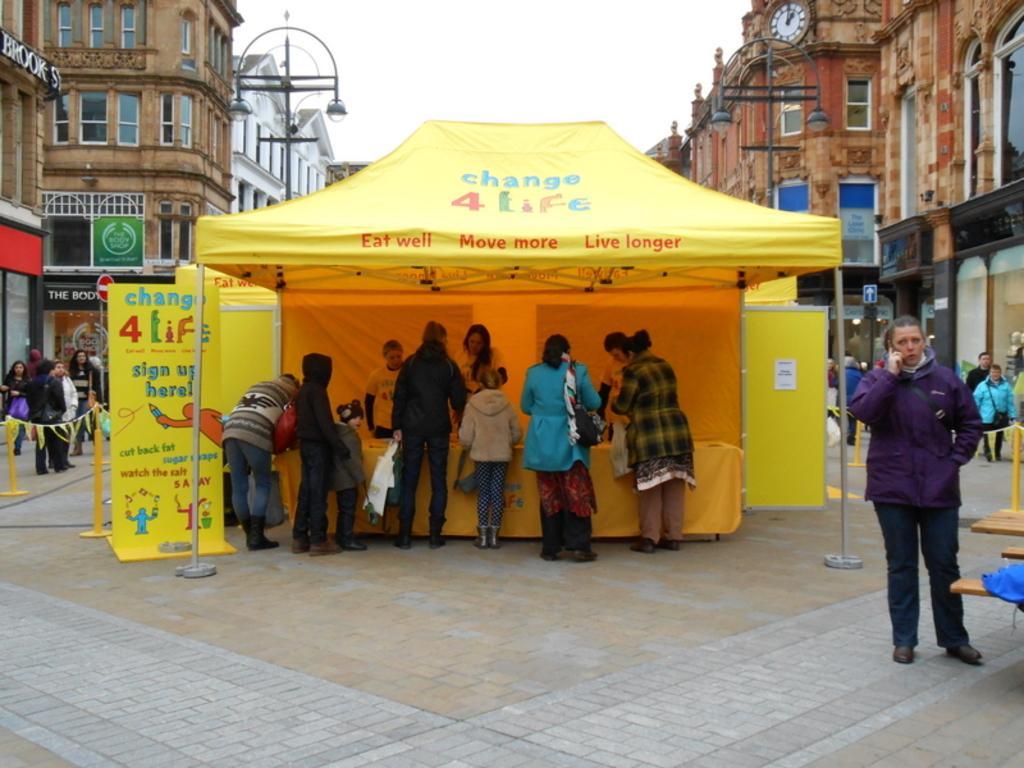In one or two sentences, can you explain what this image depicts? In this image we can see few people under a tent. On the rent we can see some text. Beside the persons we can see a banner with text. On the right side, we can see few persons and buildings. On the left side, we can see few persons, buildings and a pole with lights. At the top we can see the sky. 